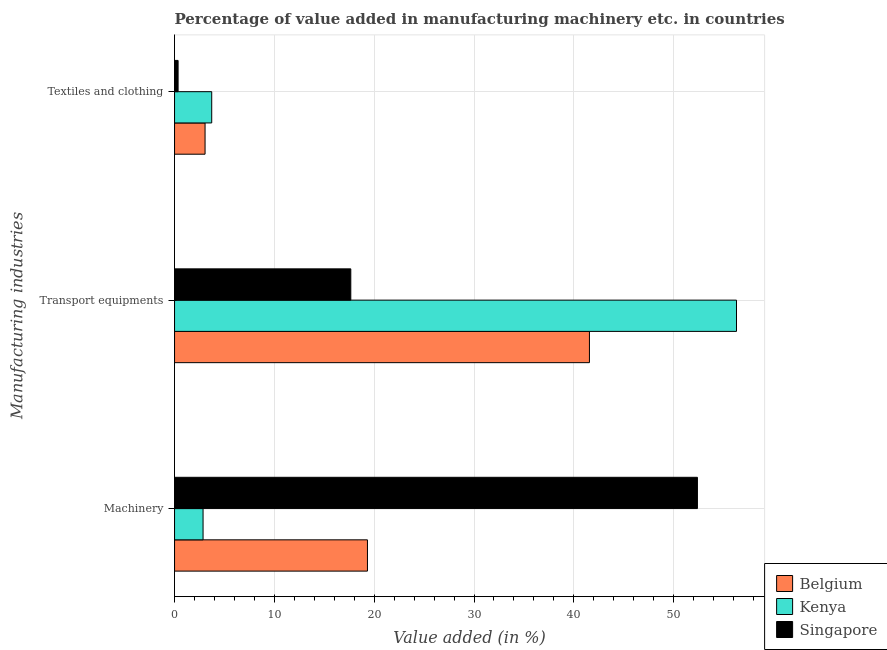Are the number of bars per tick equal to the number of legend labels?
Your response must be concise. Yes. Are the number of bars on each tick of the Y-axis equal?
Offer a very short reply. Yes. How many bars are there on the 1st tick from the top?
Your response must be concise. 3. What is the label of the 1st group of bars from the top?
Make the answer very short. Textiles and clothing. What is the value added in manufacturing textile and clothing in Belgium?
Your answer should be very brief. 3.06. Across all countries, what is the maximum value added in manufacturing textile and clothing?
Your response must be concise. 3.72. Across all countries, what is the minimum value added in manufacturing transport equipments?
Your answer should be compact. 17.66. In which country was the value added in manufacturing transport equipments maximum?
Make the answer very short. Kenya. In which country was the value added in manufacturing machinery minimum?
Ensure brevity in your answer.  Kenya. What is the total value added in manufacturing textile and clothing in the graph?
Give a very brief answer. 7.14. What is the difference between the value added in manufacturing transport equipments in Kenya and that in Singapore?
Offer a very short reply. 38.64. What is the difference between the value added in manufacturing machinery in Kenya and the value added in manufacturing transport equipments in Belgium?
Your answer should be very brief. -38.71. What is the average value added in manufacturing transport equipments per country?
Your response must be concise. 38.51. What is the difference between the value added in manufacturing machinery and value added in manufacturing textile and clothing in Kenya?
Offer a very short reply. -0.87. What is the ratio of the value added in manufacturing machinery in Belgium to that in Singapore?
Provide a succinct answer. 0.37. Is the difference between the value added in manufacturing machinery in Kenya and Singapore greater than the difference between the value added in manufacturing textile and clothing in Kenya and Singapore?
Ensure brevity in your answer.  No. What is the difference between the highest and the second highest value added in manufacturing transport equipments?
Ensure brevity in your answer.  14.73. What is the difference between the highest and the lowest value added in manufacturing machinery?
Offer a very short reply. 49.52. In how many countries, is the value added in manufacturing machinery greater than the average value added in manufacturing machinery taken over all countries?
Your answer should be compact. 1. What does the 2nd bar from the top in Textiles and clothing represents?
Provide a short and direct response. Kenya. What does the 1st bar from the bottom in Machinery represents?
Offer a very short reply. Belgium. How many countries are there in the graph?
Give a very brief answer. 3. What is the difference between two consecutive major ticks on the X-axis?
Provide a short and direct response. 10. Does the graph contain grids?
Keep it short and to the point. Yes. How are the legend labels stacked?
Your answer should be compact. Vertical. What is the title of the graph?
Keep it short and to the point. Percentage of value added in manufacturing machinery etc. in countries. What is the label or title of the X-axis?
Your response must be concise. Value added (in %). What is the label or title of the Y-axis?
Give a very brief answer. Manufacturing industries. What is the Value added (in %) in Belgium in Machinery?
Provide a succinct answer. 19.32. What is the Value added (in %) in Kenya in Machinery?
Your response must be concise. 2.86. What is the Value added (in %) in Singapore in Machinery?
Provide a short and direct response. 52.38. What is the Value added (in %) in Belgium in Transport equipments?
Your response must be concise. 41.56. What is the Value added (in %) in Kenya in Transport equipments?
Provide a succinct answer. 56.3. What is the Value added (in %) in Singapore in Transport equipments?
Offer a very short reply. 17.66. What is the Value added (in %) of Belgium in Textiles and clothing?
Your answer should be very brief. 3.06. What is the Value added (in %) of Kenya in Textiles and clothing?
Offer a very short reply. 3.72. What is the Value added (in %) in Singapore in Textiles and clothing?
Provide a short and direct response. 0.35. Across all Manufacturing industries, what is the maximum Value added (in %) of Belgium?
Make the answer very short. 41.56. Across all Manufacturing industries, what is the maximum Value added (in %) in Kenya?
Make the answer very short. 56.3. Across all Manufacturing industries, what is the maximum Value added (in %) in Singapore?
Make the answer very short. 52.38. Across all Manufacturing industries, what is the minimum Value added (in %) in Belgium?
Offer a terse response. 3.06. Across all Manufacturing industries, what is the minimum Value added (in %) in Kenya?
Your response must be concise. 2.86. Across all Manufacturing industries, what is the minimum Value added (in %) in Singapore?
Keep it short and to the point. 0.35. What is the total Value added (in %) in Belgium in the graph?
Make the answer very short. 63.94. What is the total Value added (in %) of Kenya in the graph?
Make the answer very short. 62.88. What is the total Value added (in %) of Singapore in the graph?
Provide a short and direct response. 70.39. What is the difference between the Value added (in %) in Belgium in Machinery and that in Transport equipments?
Provide a short and direct response. -22.24. What is the difference between the Value added (in %) in Kenya in Machinery and that in Transport equipments?
Offer a very short reply. -53.44. What is the difference between the Value added (in %) of Singapore in Machinery and that in Transport equipments?
Your response must be concise. 34.72. What is the difference between the Value added (in %) in Belgium in Machinery and that in Textiles and clothing?
Your response must be concise. 16.27. What is the difference between the Value added (in %) of Kenya in Machinery and that in Textiles and clothing?
Your response must be concise. -0.87. What is the difference between the Value added (in %) in Singapore in Machinery and that in Textiles and clothing?
Offer a terse response. 52.03. What is the difference between the Value added (in %) of Belgium in Transport equipments and that in Textiles and clothing?
Your response must be concise. 38.51. What is the difference between the Value added (in %) of Kenya in Transport equipments and that in Textiles and clothing?
Keep it short and to the point. 52.57. What is the difference between the Value added (in %) of Singapore in Transport equipments and that in Textiles and clothing?
Your answer should be very brief. 17.3. What is the difference between the Value added (in %) in Belgium in Machinery and the Value added (in %) in Kenya in Transport equipments?
Give a very brief answer. -36.97. What is the difference between the Value added (in %) in Belgium in Machinery and the Value added (in %) in Singapore in Transport equipments?
Provide a short and direct response. 1.67. What is the difference between the Value added (in %) in Kenya in Machinery and the Value added (in %) in Singapore in Transport equipments?
Your answer should be compact. -14.8. What is the difference between the Value added (in %) in Belgium in Machinery and the Value added (in %) in Kenya in Textiles and clothing?
Give a very brief answer. 15.6. What is the difference between the Value added (in %) in Belgium in Machinery and the Value added (in %) in Singapore in Textiles and clothing?
Offer a terse response. 18.97. What is the difference between the Value added (in %) of Kenya in Machinery and the Value added (in %) of Singapore in Textiles and clothing?
Ensure brevity in your answer.  2.5. What is the difference between the Value added (in %) of Belgium in Transport equipments and the Value added (in %) of Kenya in Textiles and clothing?
Offer a very short reply. 37.84. What is the difference between the Value added (in %) in Belgium in Transport equipments and the Value added (in %) in Singapore in Textiles and clothing?
Your response must be concise. 41.21. What is the difference between the Value added (in %) in Kenya in Transport equipments and the Value added (in %) in Singapore in Textiles and clothing?
Your response must be concise. 55.94. What is the average Value added (in %) of Belgium per Manufacturing industries?
Offer a very short reply. 21.31. What is the average Value added (in %) in Kenya per Manufacturing industries?
Offer a terse response. 20.96. What is the average Value added (in %) in Singapore per Manufacturing industries?
Your answer should be compact. 23.46. What is the difference between the Value added (in %) of Belgium and Value added (in %) of Kenya in Machinery?
Make the answer very short. 16.47. What is the difference between the Value added (in %) of Belgium and Value added (in %) of Singapore in Machinery?
Give a very brief answer. -33.06. What is the difference between the Value added (in %) of Kenya and Value added (in %) of Singapore in Machinery?
Make the answer very short. -49.52. What is the difference between the Value added (in %) in Belgium and Value added (in %) in Kenya in Transport equipments?
Your answer should be compact. -14.73. What is the difference between the Value added (in %) of Belgium and Value added (in %) of Singapore in Transport equipments?
Your answer should be compact. 23.91. What is the difference between the Value added (in %) in Kenya and Value added (in %) in Singapore in Transport equipments?
Make the answer very short. 38.64. What is the difference between the Value added (in %) of Belgium and Value added (in %) of Kenya in Textiles and clothing?
Your response must be concise. -0.67. What is the difference between the Value added (in %) in Belgium and Value added (in %) in Singapore in Textiles and clothing?
Your response must be concise. 2.7. What is the difference between the Value added (in %) of Kenya and Value added (in %) of Singapore in Textiles and clothing?
Your answer should be very brief. 3.37. What is the ratio of the Value added (in %) of Belgium in Machinery to that in Transport equipments?
Your answer should be very brief. 0.46. What is the ratio of the Value added (in %) of Kenya in Machinery to that in Transport equipments?
Ensure brevity in your answer.  0.05. What is the ratio of the Value added (in %) of Singapore in Machinery to that in Transport equipments?
Your response must be concise. 2.97. What is the ratio of the Value added (in %) of Belgium in Machinery to that in Textiles and clothing?
Give a very brief answer. 6.32. What is the ratio of the Value added (in %) of Kenya in Machinery to that in Textiles and clothing?
Make the answer very short. 0.77. What is the ratio of the Value added (in %) in Singapore in Machinery to that in Textiles and clothing?
Ensure brevity in your answer.  147.72. What is the ratio of the Value added (in %) of Belgium in Transport equipments to that in Textiles and clothing?
Give a very brief answer. 13.6. What is the ratio of the Value added (in %) of Kenya in Transport equipments to that in Textiles and clothing?
Offer a terse response. 15.12. What is the ratio of the Value added (in %) in Singapore in Transport equipments to that in Textiles and clothing?
Your answer should be very brief. 49.8. What is the difference between the highest and the second highest Value added (in %) of Belgium?
Offer a terse response. 22.24. What is the difference between the highest and the second highest Value added (in %) in Kenya?
Your answer should be compact. 52.57. What is the difference between the highest and the second highest Value added (in %) of Singapore?
Offer a terse response. 34.72. What is the difference between the highest and the lowest Value added (in %) in Belgium?
Offer a terse response. 38.51. What is the difference between the highest and the lowest Value added (in %) in Kenya?
Keep it short and to the point. 53.44. What is the difference between the highest and the lowest Value added (in %) in Singapore?
Provide a short and direct response. 52.03. 